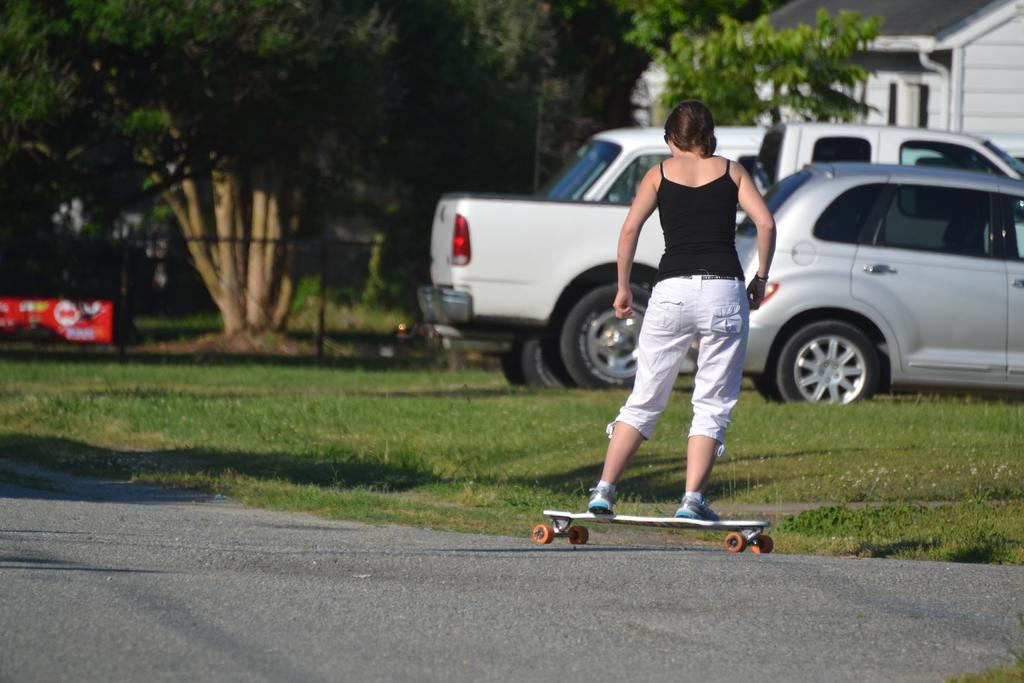Who is the main subject in the image? There is a girl in the image. What is the girl doing in the image? The girl is standing on a skateboard. Where is the skateboard located? The skateboard is on the road. What can be seen behind the girl? There are cars parked behind the girl. What is the location of the cars in relation to the building? The cars are in front of a building. What type of natural elements are visible in the image? There are trees visible in the image. What month is it in the image? The month cannot be determined from the image, as there is no information about the time of year. What type of bell can be seen hanging from the girl's skateboard? There is no bell present on the girl's skateboard in the image. 